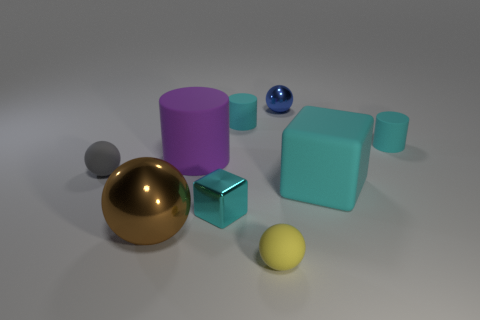Subtract all large cylinders. How many cylinders are left? 2 Subtract all brown spheres. How many spheres are left? 3 Subtract all cylinders. How many objects are left? 6 Subtract 3 spheres. How many spheres are left? 1 Subtract all purple cylinders. Subtract all purple cubes. How many cylinders are left? 2 Subtract all purple cylinders. How many red balls are left? 0 Subtract all cylinders. Subtract all tiny things. How many objects are left? 0 Add 8 brown metal balls. How many brown metal balls are left? 9 Add 4 small spheres. How many small spheres exist? 7 Subtract 0 red balls. How many objects are left? 9 